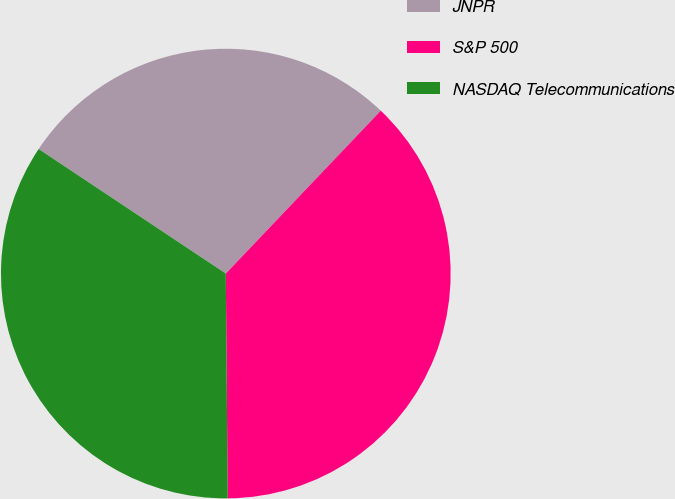<chart> <loc_0><loc_0><loc_500><loc_500><pie_chart><fcel>JNPR<fcel>S&P 500<fcel>NASDAQ Telecommunications<nl><fcel>27.76%<fcel>37.76%<fcel>34.48%<nl></chart> 